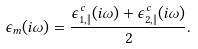<formula> <loc_0><loc_0><loc_500><loc_500>\epsilon _ { m } ( i \omega ) = \frac { \epsilon ^ { c } _ { 1 , \| } ( i \omega ) + \epsilon ^ { c } _ { 2 , \| } ( i \omega ) } { 2 } .</formula> 